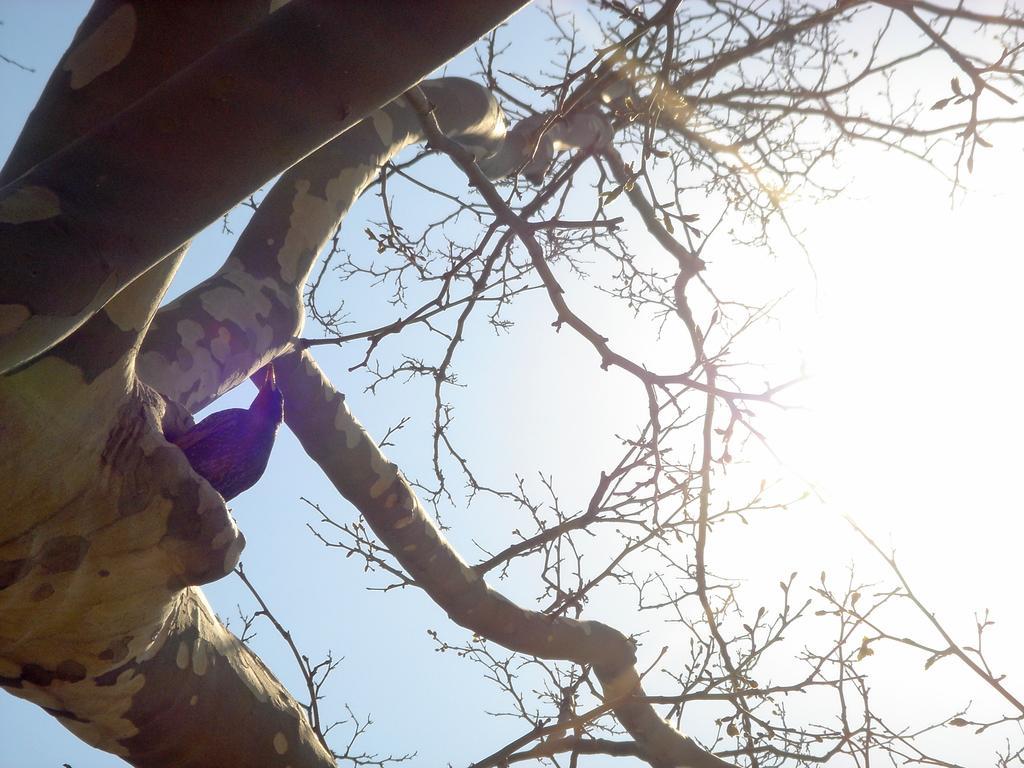How would you summarize this image in a sentence or two? In this image we can see a bird is in the hole of a tree trunk. In the background, we can see the sky with sunlight. 